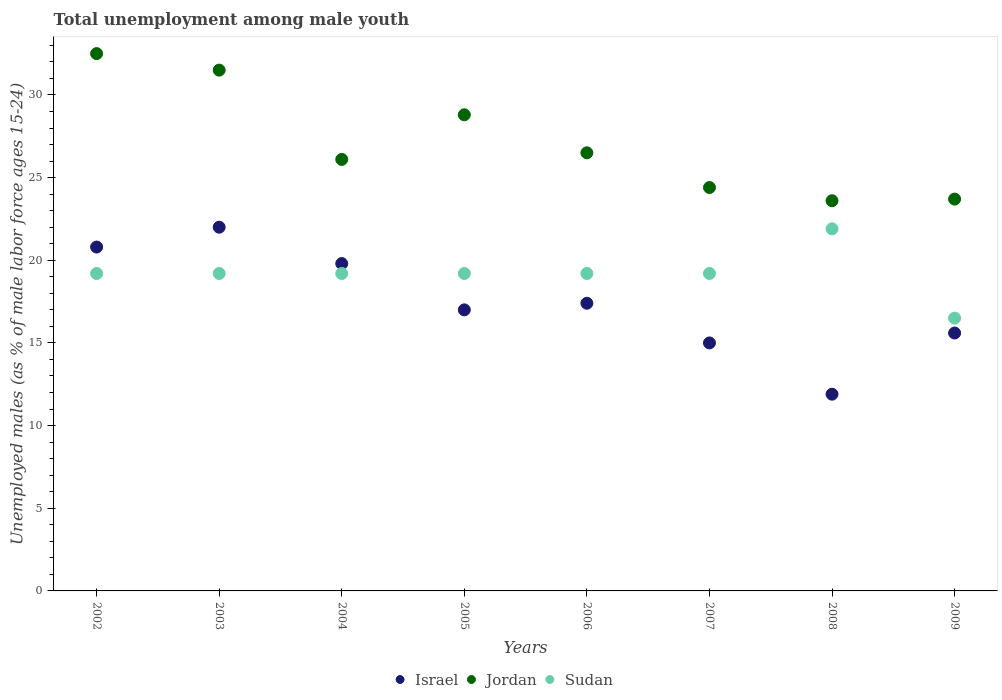What is the percentage of unemployed males in in Israel in 2003?
Provide a succinct answer. 22. Across all years, what is the maximum percentage of unemployed males in in Israel?
Offer a very short reply. 22. Across all years, what is the minimum percentage of unemployed males in in Sudan?
Provide a succinct answer. 16.5. In which year was the percentage of unemployed males in in Jordan maximum?
Keep it short and to the point. 2002. What is the total percentage of unemployed males in in Israel in the graph?
Keep it short and to the point. 139.5. What is the difference between the percentage of unemployed males in in Jordan in 2006 and that in 2009?
Your answer should be very brief. 2.8. What is the difference between the percentage of unemployed males in in Jordan in 2007 and the percentage of unemployed males in in Israel in 2008?
Offer a terse response. 12.5. What is the average percentage of unemployed males in in Jordan per year?
Keep it short and to the point. 27.14. In the year 2003, what is the difference between the percentage of unemployed males in in Jordan and percentage of unemployed males in in Israel?
Give a very brief answer. 9.5. What is the difference between the highest and the second highest percentage of unemployed males in in Sudan?
Your answer should be compact. 2.7. What is the difference between the highest and the lowest percentage of unemployed males in in Sudan?
Make the answer very short. 5.4. Is it the case that in every year, the sum of the percentage of unemployed males in in Sudan and percentage of unemployed males in in Israel  is greater than the percentage of unemployed males in in Jordan?
Your answer should be compact. Yes. Does the percentage of unemployed males in in Israel monotonically increase over the years?
Your response must be concise. No. Is the percentage of unemployed males in in Jordan strictly greater than the percentage of unemployed males in in Sudan over the years?
Keep it short and to the point. Yes. How many years are there in the graph?
Your response must be concise. 8. How many legend labels are there?
Provide a succinct answer. 3. How are the legend labels stacked?
Your answer should be very brief. Horizontal. What is the title of the graph?
Offer a very short reply. Total unemployment among male youth. What is the label or title of the Y-axis?
Keep it short and to the point. Unemployed males (as % of male labor force ages 15-24). What is the Unemployed males (as % of male labor force ages 15-24) in Israel in 2002?
Your answer should be very brief. 20.8. What is the Unemployed males (as % of male labor force ages 15-24) of Jordan in 2002?
Your answer should be compact. 32.5. What is the Unemployed males (as % of male labor force ages 15-24) in Sudan in 2002?
Keep it short and to the point. 19.2. What is the Unemployed males (as % of male labor force ages 15-24) in Jordan in 2003?
Offer a very short reply. 31.5. What is the Unemployed males (as % of male labor force ages 15-24) of Sudan in 2003?
Make the answer very short. 19.2. What is the Unemployed males (as % of male labor force ages 15-24) in Israel in 2004?
Provide a short and direct response. 19.8. What is the Unemployed males (as % of male labor force ages 15-24) in Jordan in 2004?
Ensure brevity in your answer.  26.1. What is the Unemployed males (as % of male labor force ages 15-24) in Sudan in 2004?
Your response must be concise. 19.2. What is the Unemployed males (as % of male labor force ages 15-24) of Israel in 2005?
Give a very brief answer. 17. What is the Unemployed males (as % of male labor force ages 15-24) in Jordan in 2005?
Provide a short and direct response. 28.8. What is the Unemployed males (as % of male labor force ages 15-24) of Sudan in 2005?
Provide a succinct answer. 19.2. What is the Unemployed males (as % of male labor force ages 15-24) in Israel in 2006?
Ensure brevity in your answer.  17.4. What is the Unemployed males (as % of male labor force ages 15-24) of Sudan in 2006?
Offer a terse response. 19.2. What is the Unemployed males (as % of male labor force ages 15-24) in Jordan in 2007?
Give a very brief answer. 24.4. What is the Unemployed males (as % of male labor force ages 15-24) in Sudan in 2007?
Give a very brief answer. 19.2. What is the Unemployed males (as % of male labor force ages 15-24) in Israel in 2008?
Your answer should be compact. 11.9. What is the Unemployed males (as % of male labor force ages 15-24) in Jordan in 2008?
Make the answer very short. 23.6. What is the Unemployed males (as % of male labor force ages 15-24) in Sudan in 2008?
Your response must be concise. 21.9. What is the Unemployed males (as % of male labor force ages 15-24) in Israel in 2009?
Provide a succinct answer. 15.6. What is the Unemployed males (as % of male labor force ages 15-24) in Jordan in 2009?
Offer a terse response. 23.7. What is the Unemployed males (as % of male labor force ages 15-24) of Sudan in 2009?
Ensure brevity in your answer.  16.5. Across all years, what is the maximum Unemployed males (as % of male labor force ages 15-24) in Jordan?
Make the answer very short. 32.5. Across all years, what is the maximum Unemployed males (as % of male labor force ages 15-24) in Sudan?
Offer a very short reply. 21.9. Across all years, what is the minimum Unemployed males (as % of male labor force ages 15-24) of Israel?
Give a very brief answer. 11.9. Across all years, what is the minimum Unemployed males (as % of male labor force ages 15-24) in Jordan?
Your answer should be compact. 23.6. Across all years, what is the minimum Unemployed males (as % of male labor force ages 15-24) in Sudan?
Provide a succinct answer. 16.5. What is the total Unemployed males (as % of male labor force ages 15-24) of Israel in the graph?
Your response must be concise. 139.5. What is the total Unemployed males (as % of male labor force ages 15-24) of Jordan in the graph?
Give a very brief answer. 217.1. What is the total Unemployed males (as % of male labor force ages 15-24) of Sudan in the graph?
Your answer should be compact. 153.6. What is the difference between the Unemployed males (as % of male labor force ages 15-24) of Israel in 2002 and that in 2003?
Offer a very short reply. -1.2. What is the difference between the Unemployed males (as % of male labor force ages 15-24) of Jordan in 2002 and that in 2003?
Provide a succinct answer. 1. What is the difference between the Unemployed males (as % of male labor force ages 15-24) in Sudan in 2002 and that in 2005?
Give a very brief answer. 0. What is the difference between the Unemployed males (as % of male labor force ages 15-24) in Israel in 2002 and that in 2006?
Give a very brief answer. 3.4. What is the difference between the Unemployed males (as % of male labor force ages 15-24) in Sudan in 2002 and that in 2006?
Ensure brevity in your answer.  0. What is the difference between the Unemployed males (as % of male labor force ages 15-24) of Israel in 2002 and that in 2007?
Give a very brief answer. 5.8. What is the difference between the Unemployed males (as % of male labor force ages 15-24) of Jordan in 2002 and that in 2007?
Make the answer very short. 8.1. What is the difference between the Unemployed males (as % of male labor force ages 15-24) in Israel in 2002 and that in 2008?
Offer a very short reply. 8.9. What is the difference between the Unemployed males (as % of male labor force ages 15-24) in Jordan in 2002 and that in 2008?
Make the answer very short. 8.9. What is the difference between the Unemployed males (as % of male labor force ages 15-24) of Sudan in 2002 and that in 2008?
Give a very brief answer. -2.7. What is the difference between the Unemployed males (as % of male labor force ages 15-24) of Israel in 2002 and that in 2009?
Keep it short and to the point. 5.2. What is the difference between the Unemployed males (as % of male labor force ages 15-24) in Sudan in 2002 and that in 2009?
Your response must be concise. 2.7. What is the difference between the Unemployed males (as % of male labor force ages 15-24) of Israel in 2003 and that in 2004?
Offer a terse response. 2.2. What is the difference between the Unemployed males (as % of male labor force ages 15-24) of Sudan in 2003 and that in 2005?
Your response must be concise. 0. What is the difference between the Unemployed males (as % of male labor force ages 15-24) in Israel in 2003 and that in 2006?
Provide a succinct answer. 4.6. What is the difference between the Unemployed males (as % of male labor force ages 15-24) in Jordan in 2003 and that in 2006?
Your response must be concise. 5. What is the difference between the Unemployed males (as % of male labor force ages 15-24) in Israel in 2003 and that in 2007?
Your answer should be very brief. 7. What is the difference between the Unemployed males (as % of male labor force ages 15-24) in Jordan in 2003 and that in 2007?
Give a very brief answer. 7.1. What is the difference between the Unemployed males (as % of male labor force ages 15-24) of Israel in 2003 and that in 2008?
Make the answer very short. 10.1. What is the difference between the Unemployed males (as % of male labor force ages 15-24) of Sudan in 2003 and that in 2008?
Give a very brief answer. -2.7. What is the difference between the Unemployed males (as % of male labor force ages 15-24) in Sudan in 2003 and that in 2009?
Your answer should be compact. 2.7. What is the difference between the Unemployed males (as % of male labor force ages 15-24) in Jordan in 2004 and that in 2005?
Your answer should be compact. -2.7. What is the difference between the Unemployed males (as % of male labor force ages 15-24) in Israel in 2004 and that in 2006?
Your response must be concise. 2.4. What is the difference between the Unemployed males (as % of male labor force ages 15-24) of Jordan in 2004 and that in 2006?
Make the answer very short. -0.4. What is the difference between the Unemployed males (as % of male labor force ages 15-24) in Israel in 2004 and that in 2007?
Give a very brief answer. 4.8. What is the difference between the Unemployed males (as % of male labor force ages 15-24) of Sudan in 2004 and that in 2007?
Your response must be concise. 0. What is the difference between the Unemployed males (as % of male labor force ages 15-24) of Israel in 2004 and that in 2008?
Ensure brevity in your answer.  7.9. What is the difference between the Unemployed males (as % of male labor force ages 15-24) in Sudan in 2004 and that in 2008?
Provide a succinct answer. -2.7. What is the difference between the Unemployed males (as % of male labor force ages 15-24) in Israel in 2004 and that in 2009?
Provide a succinct answer. 4.2. What is the difference between the Unemployed males (as % of male labor force ages 15-24) in Sudan in 2004 and that in 2009?
Provide a succinct answer. 2.7. What is the difference between the Unemployed males (as % of male labor force ages 15-24) of Israel in 2005 and that in 2006?
Provide a short and direct response. -0.4. What is the difference between the Unemployed males (as % of male labor force ages 15-24) in Jordan in 2005 and that in 2006?
Your response must be concise. 2.3. What is the difference between the Unemployed males (as % of male labor force ages 15-24) in Jordan in 2005 and that in 2007?
Make the answer very short. 4.4. What is the difference between the Unemployed males (as % of male labor force ages 15-24) of Sudan in 2005 and that in 2008?
Offer a very short reply. -2.7. What is the difference between the Unemployed males (as % of male labor force ages 15-24) of Sudan in 2005 and that in 2009?
Your answer should be compact. 2.7. What is the difference between the Unemployed males (as % of male labor force ages 15-24) in Jordan in 2006 and that in 2008?
Provide a short and direct response. 2.9. What is the difference between the Unemployed males (as % of male labor force ages 15-24) in Sudan in 2006 and that in 2008?
Offer a very short reply. -2.7. What is the difference between the Unemployed males (as % of male labor force ages 15-24) of Jordan in 2006 and that in 2009?
Your answer should be very brief. 2.8. What is the difference between the Unemployed males (as % of male labor force ages 15-24) of Jordan in 2007 and that in 2008?
Give a very brief answer. 0.8. What is the difference between the Unemployed males (as % of male labor force ages 15-24) in Israel in 2007 and that in 2009?
Keep it short and to the point. -0.6. What is the difference between the Unemployed males (as % of male labor force ages 15-24) in Jordan in 2007 and that in 2009?
Offer a terse response. 0.7. What is the difference between the Unemployed males (as % of male labor force ages 15-24) in Sudan in 2007 and that in 2009?
Your answer should be compact. 2.7. What is the difference between the Unemployed males (as % of male labor force ages 15-24) of Israel in 2008 and that in 2009?
Your response must be concise. -3.7. What is the difference between the Unemployed males (as % of male labor force ages 15-24) in Jordan in 2008 and that in 2009?
Offer a terse response. -0.1. What is the difference between the Unemployed males (as % of male labor force ages 15-24) in Sudan in 2008 and that in 2009?
Ensure brevity in your answer.  5.4. What is the difference between the Unemployed males (as % of male labor force ages 15-24) in Israel in 2002 and the Unemployed males (as % of male labor force ages 15-24) in Jordan in 2003?
Provide a short and direct response. -10.7. What is the difference between the Unemployed males (as % of male labor force ages 15-24) in Israel in 2002 and the Unemployed males (as % of male labor force ages 15-24) in Sudan in 2003?
Your answer should be very brief. 1.6. What is the difference between the Unemployed males (as % of male labor force ages 15-24) in Israel in 2002 and the Unemployed males (as % of male labor force ages 15-24) in Jordan in 2004?
Ensure brevity in your answer.  -5.3. What is the difference between the Unemployed males (as % of male labor force ages 15-24) of Israel in 2002 and the Unemployed males (as % of male labor force ages 15-24) of Jordan in 2005?
Make the answer very short. -8. What is the difference between the Unemployed males (as % of male labor force ages 15-24) of Jordan in 2002 and the Unemployed males (as % of male labor force ages 15-24) of Sudan in 2006?
Your response must be concise. 13.3. What is the difference between the Unemployed males (as % of male labor force ages 15-24) in Israel in 2002 and the Unemployed males (as % of male labor force ages 15-24) in Sudan in 2007?
Offer a terse response. 1.6. What is the difference between the Unemployed males (as % of male labor force ages 15-24) in Jordan in 2002 and the Unemployed males (as % of male labor force ages 15-24) in Sudan in 2007?
Offer a very short reply. 13.3. What is the difference between the Unemployed males (as % of male labor force ages 15-24) of Israel in 2002 and the Unemployed males (as % of male labor force ages 15-24) of Jordan in 2008?
Offer a terse response. -2.8. What is the difference between the Unemployed males (as % of male labor force ages 15-24) in Israel in 2002 and the Unemployed males (as % of male labor force ages 15-24) in Sudan in 2008?
Provide a short and direct response. -1.1. What is the difference between the Unemployed males (as % of male labor force ages 15-24) in Jordan in 2002 and the Unemployed males (as % of male labor force ages 15-24) in Sudan in 2008?
Offer a terse response. 10.6. What is the difference between the Unemployed males (as % of male labor force ages 15-24) in Israel in 2002 and the Unemployed males (as % of male labor force ages 15-24) in Jordan in 2009?
Provide a short and direct response. -2.9. What is the difference between the Unemployed males (as % of male labor force ages 15-24) in Israel in 2002 and the Unemployed males (as % of male labor force ages 15-24) in Sudan in 2009?
Provide a short and direct response. 4.3. What is the difference between the Unemployed males (as % of male labor force ages 15-24) of Israel in 2003 and the Unemployed males (as % of male labor force ages 15-24) of Jordan in 2004?
Provide a short and direct response. -4.1. What is the difference between the Unemployed males (as % of male labor force ages 15-24) in Israel in 2003 and the Unemployed males (as % of male labor force ages 15-24) in Sudan in 2005?
Provide a succinct answer. 2.8. What is the difference between the Unemployed males (as % of male labor force ages 15-24) of Jordan in 2003 and the Unemployed males (as % of male labor force ages 15-24) of Sudan in 2005?
Provide a succinct answer. 12.3. What is the difference between the Unemployed males (as % of male labor force ages 15-24) of Israel in 2003 and the Unemployed males (as % of male labor force ages 15-24) of Jordan in 2006?
Your answer should be very brief. -4.5. What is the difference between the Unemployed males (as % of male labor force ages 15-24) in Israel in 2003 and the Unemployed males (as % of male labor force ages 15-24) in Sudan in 2006?
Offer a terse response. 2.8. What is the difference between the Unemployed males (as % of male labor force ages 15-24) in Israel in 2003 and the Unemployed males (as % of male labor force ages 15-24) in Jordan in 2007?
Provide a short and direct response. -2.4. What is the difference between the Unemployed males (as % of male labor force ages 15-24) in Israel in 2003 and the Unemployed males (as % of male labor force ages 15-24) in Jordan in 2008?
Your answer should be compact. -1.6. What is the difference between the Unemployed males (as % of male labor force ages 15-24) in Israel in 2003 and the Unemployed males (as % of male labor force ages 15-24) in Jordan in 2009?
Provide a short and direct response. -1.7. What is the difference between the Unemployed males (as % of male labor force ages 15-24) in Israel in 2003 and the Unemployed males (as % of male labor force ages 15-24) in Sudan in 2009?
Your answer should be compact. 5.5. What is the difference between the Unemployed males (as % of male labor force ages 15-24) of Israel in 2004 and the Unemployed males (as % of male labor force ages 15-24) of Jordan in 2005?
Make the answer very short. -9. What is the difference between the Unemployed males (as % of male labor force ages 15-24) in Israel in 2004 and the Unemployed males (as % of male labor force ages 15-24) in Jordan in 2006?
Provide a succinct answer. -6.7. What is the difference between the Unemployed males (as % of male labor force ages 15-24) in Israel in 2004 and the Unemployed males (as % of male labor force ages 15-24) in Jordan in 2007?
Your response must be concise. -4.6. What is the difference between the Unemployed males (as % of male labor force ages 15-24) in Israel in 2004 and the Unemployed males (as % of male labor force ages 15-24) in Sudan in 2007?
Keep it short and to the point. 0.6. What is the difference between the Unemployed males (as % of male labor force ages 15-24) in Israel in 2004 and the Unemployed males (as % of male labor force ages 15-24) in Sudan in 2008?
Provide a short and direct response. -2.1. What is the difference between the Unemployed males (as % of male labor force ages 15-24) in Israel in 2004 and the Unemployed males (as % of male labor force ages 15-24) in Jordan in 2009?
Ensure brevity in your answer.  -3.9. What is the difference between the Unemployed males (as % of male labor force ages 15-24) of Israel in 2005 and the Unemployed males (as % of male labor force ages 15-24) of Sudan in 2006?
Keep it short and to the point. -2.2. What is the difference between the Unemployed males (as % of male labor force ages 15-24) in Israel in 2005 and the Unemployed males (as % of male labor force ages 15-24) in Jordan in 2007?
Offer a very short reply. -7.4. What is the difference between the Unemployed males (as % of male labor force ages 15-24) of Jordan in 2005 and the Unemployed males (as % of male labor force ages 15-24) of Sudan in 2007?
Provide a short and direct response. 9.6. What is the difference between the Unemployed males (as % of male labor force ages 15-24) of Israel in 2005 and the Unemployed males (as % of male labor force ages 15-24) of Jordan in 2008?
Your response must be concise. -6.6. What is the difference between the Unemployed males (as % of male labor force ages 15-24) in Jordan in 2005 and the Unemployed males (as % of male labor force ages 15-24) in Sudan in 2008?
Make the answer very short. 6.9. What is the difference between the Unemployed males (as % of male labor force ages 15-24) of Israel in 2005 and the Unemployed males (as % of male labor force ages 15-24) of Jordan in 2009?
Make the answer very short. -6.7. What is the difference between the Unemployed males (as % of male labor force ages 15-24) of Jordan in 2005 and the Unemployed males (as % of male labor force ages 15-24) of Sudan in 2009?
Your response must be concise. 12.3. What is the difference between the Unemployed males (as % of male labor force ages 15-24) of Israel in 2006 and the Unemployed males (as % of male labor force ages 15-24) of Jordan in 2007?
Your answer should be very brief. -7. What is the difference between the Unemployed males (as % of male labor force ages 15-24) in Israel in 2006 and the Unemployed males (as % of male labor force ages 15-24) in Sudan in 2007?
Offer a terse response. -1.8. What is the difference between the Unemployed males (as % of male labor force ages 15-24) of Jordan in 2006 and the Unemployed males (as % of male labor force ages 15-24) of Sudan in 2007?
Offer a terse response. 7.3. What is the difference between the Unemployed males (as % of male labor force ages 15-24) in Israel in 2006 and the Unemployed males (as % of male labor force ages 15-24) in Jordan in 2008?
Your response must be concise. -6.2. What is the difference between the Unemployed males (as % of male labor force ages 15-24) in Israel in 2006 and the Unemployed males (as % of male labor force ages 15-24) in Sudan in 2008?
Your answer should be compact. -4.5. What is the difference between the Unemployed males (as % of male labor force ages 15-24) in Jordan in 2006 and the Unemployed males (as % of male labor force ages 15-24) in Sudan in 2008?
Offer a terse response. 4.6. What is the difference between the Unemployed males (as % of male labor force ages 15-24) in Israel in 2006 and the Unemployed males (as % of male labor force ages 15-24) in Jordan in 2009?
Give a very brief answer. -6.3. What is the difference between the Unemployed males (as % of male labor force ages 15-24) in Israel in 2006 and the Unemployed males (as % of male labor force ages 15-24) in Sudan in 2009?
Your response must be concise. 0.9. What is the difference between the Unemployed males (as % of male labor force ages 15-24) of Jordan in 2006 and the Unemployed males (as % of male labor force ages 15-24) of Sudan in 2009?
Ensure brevity in your answer.  10. What is the difference between the Unemployed males (as % of male labor force ages 15-24) of Israel in 2007 and the Unemployed males (as % of male labor force ages 15-24) of Sudan in 2008?
Give a very brief answer. -6.9. What is the difference between the Unemployed males (as % of male labor force ages 15-24) of Jordan in 2007 and the Unemployed males (as % of male labor force ages 15-24) of Sudan in 2008?
Offer a very short reply. 2.5. What is the difference between the Unemployed males (as % of male labor force ages 15-24) in Israel in 2007 and the Unemployed males (as % of male labor force ages 15-24) in Jordan in 2009?
Offer a terse response. -8.7. What is the difference between the Unemployed males (as % of male labor force ages 15-24) in Israel in 2008 and the Unemployed males (as % of male labor force ages 15-24) in Jordan in 2009?
Your response must be concise. -11.8. What is the difference between the Unemployed males (as % of male labor force ages 15-24) of Israel in 2008 and the Unemployed males (as % of male labor force ages 15-24) of Sudan in 2009?
Your response must be concise. -4.6. What is the difference between the Unemployed males (as % of male labor force ages 15-24) of Jordan in 2008 and the Unemployed males (as % of male labor force ages 15-24) of Sudan in 2009?
Ensure brevity in your answer.  7.1. What is the average Unemployed males (as % of male labor force ages 15-24) of Israel per year?
Your answer should be very brief. 17.44. What is the average Unemployed males (as % of male labor force ages 15-24) in Jordan per year?
Provide a short and direct response. 27.14. What is the average Unemployed males (as % of male labor force ages 15-24) of Sudan per year?
Ensure brevity in your answer.  19.2. In the year 2002, what is the difference between the Unemployed males (as % of male labor force ages 15-24) of Israel and Unemployed males (as % of male labor force ages 15-24) of Sudan?
Your answer should be very brief. 1.6. In the year 2003, what is the difference between the Unemployed males (as % of male labor force ages 15-24) in Israel and Unemployed males (as % of male labor force ages 15-24) in Jordan?
Give a very brief answer. -9.5. In the year 2003, what is the difference between the Unemployed males (as % of male labor force ages 15-24) of Israel and Unemployed males (as % of male labor force ages 15-24) of Sudan?
Offer a very short reply. 2.8. In the year 2003, what is the difference between the Unemployed males (as % of male labor force ages 15-24) of Jordan and Unemployed males (as % of male labor force ages 15-24) of Sudan?
Your answer should be very brief. 12.3. In the year 2004, what is the difference between the Unemployed males (as % of male labor force ages 15-24) of Israel and Unemployed males (as % of male labor force ages 15-24) of Jordan?
Your response must be concise. -6.3. In the year 2005, what is the difference between the Unemployed males (as % of male labor force ages 15-24) in Israel and Unemployed males (as % of male labor force ages 15-24) in Jordan?
Give a very brief answer. -11.8. In the year 2005, what is the difference between the Unemployed males (as % of male labor force ages 15-24) of Israel and Unemployed males (as % of male labor force ages 15-24) of Sudan?
Your response must be concise. -2.2. In the year 2005, what is the difference between the Unemployed males (as % of male labor force ages 15-24) in Jordan and Unemployed males (as % of male labor force ages 15-24) in Sudan?
Your answer should be compact. 9.6. In the year 2006, what is the difference between the Unemployed males (as % of male labor force ages 15-24) of Israel and Unemployed males (as % of male labor force ages 15-24) of Jordan?
Provide a short and direct response. -9.1. In the year 2006, what is the difference between the Unemployed males (as % of male labor force ages 15-24) in Israel and Unemployed males (as % of male labor force ages 15-24) in Sudan?
Your answer should be compact. -1.8. In the year 2007, what is the difference between the Unemployed males (as % of male labor force ages 15-24) in Israel and Unemployed males (as % of male labor force ages 15-24) in Jordan?
Offer a terse response. -9.4. In the year 2008, what is the difference between the Unemployed males (as % of male labor force ages 15-24) in Jordan and Unemployed males (as % of male labor force ages 15-24) in Sudan?
Your answer should be very brief. 1.7. In the year 2009, what is the difference between the Unemployed males (as % of male labor force ages 15-24) in Israel and Unemployed males (as % of male labor force ages 15-24) in Jordan?
Keep it short and to the point. -8.1. In the year 2009, what is the difference between the Unemployed males (as % of male labor force ages 15-24) in Jordan and Unemployed males (as % of male labor force ages 15-24) in Sudan?
Ensure brevity in your answer.  7.2. What is the ratio of the Unemployed males (as % of male labor force ages 15-24) of Israel in 2002 to that in 2003?
Provide a short and direct response. 0.95. What is the ratio of the Unemployed males (as % of male labor force ages 15-24) in Jordan in 2002 to that in 2003?
Your response must be concise. 1.03. What is the ratio of the Unemployed males (as % of male labor force ages 15-24) in Sudan in 2002 to that in 2003?
Your answer should be very brief. 1. What is the ratio of the Unemployed males (as % of male labor force ages 15-24) of Israel in 2002 to that in 2004?
Keep it short and to the point. 1.05. What is the ratio of the Unemployed males (as % of male labor force ages 15-24) in Jordan in 2002 to that in 2004?
Keep it short and to the point. 1.25. What is the ratio of the Unemployed males (as % of male labor force ages 15-24) of Israel in 2002 to that in 2005?
Keep it short and to the point. 1.22. What is the ratio of the Unemployed males (as % of male labor force ages 15-24) in Jordan in 2002 to that in 2005?
Make the answer very short. 1.13. What is the ratio of the Unemployed males (as % of male labor force ages 15-24) in Sudan in 2002 to that in 2005?
Ensure brevity in your answer.  1. What is the ratio of the Unemployed males (as % of male labor force ages 15-24) of Israel in 2002 to that in 2006?
Provide a short and direct response. 1.2. What is the ratio of the Unemployed males (as % of male labor force ages 15-24) in Jordan in 2002 to that in 2006?
Provide a short and direct response. 1.23. What is the ratio of the Unemployed males (as % of male labor force ages 15-24) of Sudan in 2002 to that in 2006?
Give a very brief answer. 1. What is the ratio of the Unemployed males (as % of male labor force ages 15-24) in Israel in 2002 to that in 2007?
Your response must be concise. 1.39. What is the ratio of the Unemployed males (as % of male labor force ages 15-24) of Jordan in 2002 to that in 2007?
Provide a short and direct response. 1.33. What is the ratio of the Unemployed males (as % of male labor force ages 15-24) in Israel in 2002 to that in 2008?
Keep it short and to the point. 1.75. What is the ratio of the Unemployed males (as % of male labor force ages 15-24) of Jordan in 2002 to that in 2008?
Provide a short and direct response. 1.38. What is the ratio of the Unemployed males (as % of male labor force ages 15-24) in Sudan in 2002 to that in 2008?
Provide a succinct answer. 0.88. What is the ratio of the Unemployed males (as % of male labor force ages 15-24) of Israel in 2002 to that in 2009?
Ensure brevity in your answer.  1.33. What is the ratio of the Unemployed males (as % of male labor force ages 15-24) of Jordan in 2002 to that in 2009?
Your answer should be compact. 1.37. What is the ratio of the Unemployed males (as % of male labor force ages 15-24) of Sudan in 2002 to that in 2009?
Your response must be concise. 1.16. What is the ratio of the Unemployed males (as % of male labor force ages 15-24) of Jordan in 2003 to that in 2004?
Ensure brevity in your answer.  1.21. What is the ratio of the Unemployed males (as % of male labor force ages 15-24) in Sudan in 2003 to that in 2004?
Ensure brevity in your answer.  1. What is the ratio of the Unemployed males (as % of male labor force ages 15-24) in Israel in 2003 to that in 2005?
Ensure brevity in your answer.  1.29. What is the ratio of the Unemployed males (as % of male labor force ages 15-24) of Jordan in 2003 to that in 2005?
Ensure brevity in your answer.  1.09. What is the ratio of the Unemployed males (as % of male labor force ages 15-24) of Israel in 2003 to that in 2006?
Your answer should be compact. 1.26. What is the ratio of the Unemployed males (as % of male labor force ages 15-24) of Jordan in 2003 to that in 2006?
Ensure brevity in your answer.  1.19. What is the ratio of the Unemployed males (as % of male labor force ages 15-24) in Sudan in 2003 to that in 2006?
Your answer should be very brief. 1. What is the ratio of the Unemployed males (as % of male labor force ages 15-24) of Israel in 2003 to that in 2007?
Provide a short and direct response. 1.47. What is the ratio of the Unemployed males (as % of male labor force ages 15-24) in Jordan in 2003 to that in 2007?
Offer a terse response. 1.29. What is the ratio of the Unemployed males (as % of male labor force ages 15-24) in Sudan in 2003 to that in 2007?
Ensure brevity in your answer.  1. What is the ratio of the Unemployed males (as % of male labor force ages 15-24) of Israel in 2003 to that in 2008?
Provide a succinct answer. 1.85. What is the ratio of the Unemployed males (as % of male labor force ages 15-24) of Jordan in 2003 to that in 2008?
Your response must be concise. 1.33. What is the ratio of the Unemployed males (as % of male labor force ages 15-24) in Sudan in 2003 to that in 2008?
Your response must be concise. 0.88. What is the ratio of the Unemployed males (as % of male labor force ages 15-24) of Israel in 2003 to that in 2009?
Keep it short and to the point. 1.41. What is the ratio of the Unemployed males (as % of male labor force ages 15-24) of Jordan in 2003 to that in 2009?
Ensure brevity in your answer.  1.33. What is the ratio of the Unemployed males (as % of male labor force ages 15-24) in Sudan in 2003 to that in 2009?
Make the answer very short. 1.16. What is the ratio of the Unemployed males (as % of male labor force ages 15-24) of Israel in 2004 to that in 2005?
Offer a terse response. 1.16. What is the ratio of the Unemployed males (as % of male labor force ages 15-24) of Jordan in 2004 to that in 2005?
Provide a short and direct response. 0.91. What is the ratio of the Unemployed males (as % of male labor force ages 15-24) in Israel in 2004 to that in 2006?
Your answer should be very brief. 1.14. What is the ratio of the Unemployed males (as % of male labor force ages 15-24) of Jordan in 2004 to that in 2006?
Your answer should be compact. 0.98. What is the ratio of the Unemployed males (as % of male labor force ages 15-24) of Sudan in 2004 to that in 2006?
Your answer should be compact. 1. What is the ratio of the Unemployed males (as % of male labor force ages 15-24) in Israel in 2004 to that in 2007?
Give a very brief answer. 1.32. What is the ratio of the Unemployed males (as % of male labor force ages 15-24) in Jordan in 2004 to that in 2007?
Give a very brief answer. 1.07. What is the ratio of the Unemployed males (as % of male labor force ages 15-24) in Israel in 2004 to that in 2008?
Your response must be concise. 1.66. What is the ratio of the Unemployed males (as % of male labor force ages 15-24) of Jordan in 2004 to that in 2008?
Offer a very short reply. 1.11. What is the ratio of the Unemployed males (as % of male labor force ages 15-24) of Sudan in 2004 to that in 2008?
Your answer should be compact. 0.88. What is the ratio of the Unemployed males (as % of male labor force ages 15-24) in Israel in 2004 to that in 2009?
Provide a short and direct response. 1.27. What is the ratio of the Unemployed males (as % of male labor force ages 15-24) in Jordan in 2004 to that in 2009?
Ensure brevity in your answer.  1.1. What is the ratio of the Unemployed males (as % of male labor force ages 15-24) in Sudan in 2004 to that in 2009?
Your answer should be compact. 1.16. What is the ratio of the Unemployed males (as % of male labor force ages 15-24) in Israel in 2005 to that in 2006?
Offer a terse response. 0.98. What is the ratio of the Unemployed males (as % of male labor force ages 15-24) in Jordan in 2005 to that in 2006?
Make the answer very short. 1.09. What is the ratio of the Unemployed males (as % of male labor force ages 15-24) in Israel in 2005 to that in 2007?
Make the answer very short. 1.13. What is the ratio of the Unemployed males (as % of male labor force ages 15-24) of Jordan in 2005 to that in 2007?
Provide a succinct answer. 1.18. What is the ratio of the Unemployed males (as % of male labor force ages 15-24) of Israel in 2005 to that in 2008?
Ensure brevity in your answer.  1.43. What is the ratio of the Unemployed males (as % of male labor force ages 15-24) in Jordan in 2005 to that in 2008?
Make the answer very short. 1.22. What is the ratio of the Unemployed males (as % of male labor force ages 15-24) of Sudan in 2005 to that in 2008?
Keep it short and to the point. 0.88. What is the ratio of the Unemployed males (as % of male labor force ages 15-24) of Israel in 2005 to that in 2009?
Offer a very short reply. 1.09. What is the ratio of the Unemployed males (as % of male labor force ages 15-24) in Jordan in 2005 to that in 2009?
Give a very brief answer. 1.22. What is the ratio of the Unemployed males (as % of male labor force ages 15-24) of Sudan in 2005 to that in 2009?
Provide a succinct answer. 1.16. What is the ratio of the Unemployed males (as % of male labor force ages 15-24) of Israel in 2006 to that in 2007?
Your answer should be compact. 1.16. What is the ratio of the Unemployed males (as % of male labor force ages 15-24) of Jordan in 2006 to that in 2007?
Provide a succinct answer. 1.09. What is the ratio of the Unemployed males (as % of male labor force ages 15-24) of Israel in 2006 to that in 2008?
Keep it short and to the point. 1.46. What is the ratio of the Unemployed males (as % of male labor force ages 15-24) of Jordan in 2006 to that in 2008?
Keep it short and to the point. 1.12. What is the ratio of the Unemployed males (as % of male labor force ages 15-24) in Sudan in 2006 to that in 2008?
Your response must be concise. 0.88. What is the ratio of the Unemployed males (as % of male labor force ages 15-24) in Israel in 2006 to that in 2009?
Your response must be concise. 1.12. What is the ratio of the Unemployed males (as % of male labor force ages 15-24) in Jordan in 2006 to that in 2009?
Give a very brief answer. 1.12. What is the ratio of the Unemployed males (as % of male labor force ages 15-24) of Sudan in 2006 to that in 2009?
Make the answer very short. 1.16. What is the ratio of the Unemployed males (as % of male labor force ages 15-24) of Israel in 2007 to that in 2008?
Your response must be concise. 1.26. What is the ratio of the Unemployed males (as % of male labor force ages 15-24) of Jordan in 2007 to that in 2008?
Provide a succinct answer. 1.03. What is the ratio of the Unemployed males (as % of male labor force ages 15-24) in Sudan in 2007 to that in 2008?
Keep it short and to the point. 0.88. What is the ratio of the Unemployed males (as % of male labor force ages 15-24) in Israel in 2007 to that in 2009?
Give a very brief answer. 0.96. What is the ratio of the Unemployed males (as % of male labor force ages 15-24) in Jordan in 2007 to that in 2009?
Provide a succinct answer. 1.03. What is the ratio of the Unemployed males (as % of male labor force ages 15-24) in Sudan in 2007 to that in 2009?
Ensure brevity in your answer.  1.16. What is the ratio of the Unemployed males (as % of male labor force ages 15-24) of Israel in 2008 to that in 2009?
Offer a terse response. 0.76. What is the ratio of the Unemployed males (as % of male labor force ages 15-24) of Jordan in 2008 to that in 2009?
Offer a terse response. 1. What is the ratio of the Unemployed males (as % of male labor force ages 15-24) of Sudan in 2008 to that in 2009?
Provide a succinct answer. 1.33. What is the difference between the highest and the second highest Unemployed males (as % of male labor force ages 15-24) of Israel?
Give a very brief answer. 1.2. What is the difference between the highest and the second highest Unemployed males (as % of male labor force ages 15-24) in Jordan?
Keep it short and to the point. 1. What is the difference between the highest and the second highest Unemployed males (as % of male labor force ages 15-24) of Sudan?
Offer a very short reply. 2.7. 